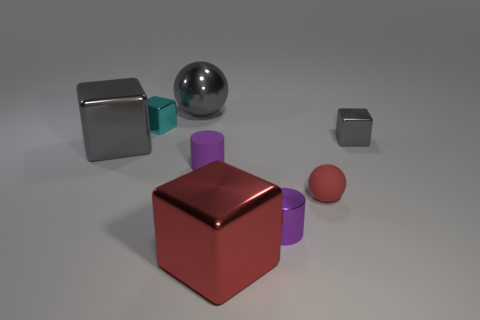Is there any source of light visible in this image? No direct source of light is visible in this image. However, the shadows and highlights on the objects suggest that the light source is located above the scene, likely out of frame.  How does the lighting affect the mood of the image? The soft lighting creates a neutral and calm mood, with gentle shadows that give the image a serene and somewhat sterile appearance, typical of a controlled studio setting. 